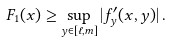<formula> <loc_0><loc_0><loc_500><loc_500>F _ { 1 } ( x ) \geq \sup _ { y \in [ \ell , m ] } | f ^ { \prime } _ { y } ( x , y ) | \, .</formula> 